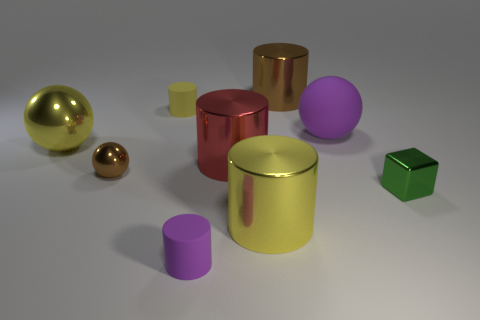Subtract all yellow cylinders. How many cylinders are left? 3 Subtract all red cubes. How many yellow cylinders are left? 2 Subtract all purple cylinders. How many cylinders are left? 4 Subtract 1 spheres. How many spheres are left? 2 Subtract all green cylinders. Subtract all green blocks. How many cylinders are left? 5 Add 1 brown metallic cylinders. How many objects exist? 10 Subtract all blocks. How many objects are left? 8 Add 3 green shiny objects. How many green shiny objects are left? 4 Add 8 metallic balls. How many metallic balls exist? 10 Subtract 0 gray cylinders. How many objects are left? 9 